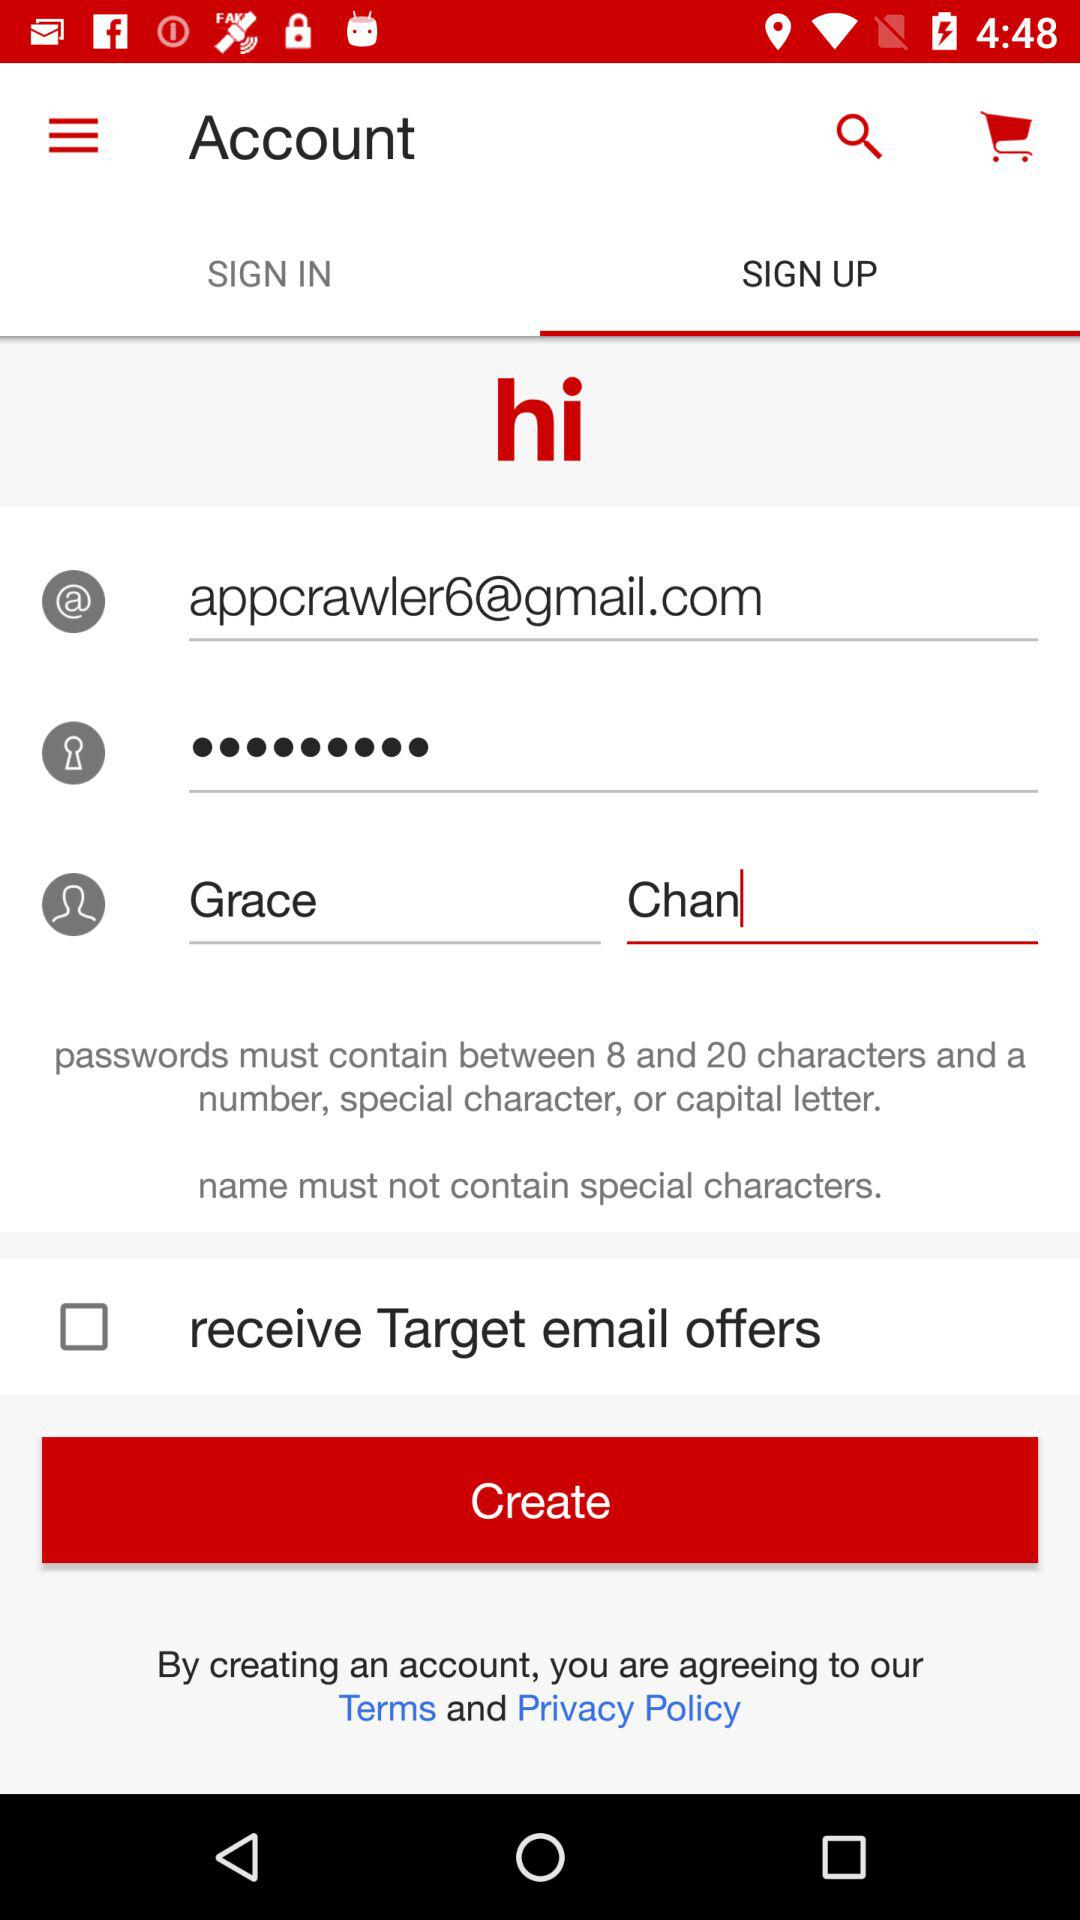What is the email address? The email address is appcrawler6@gmail.com. 